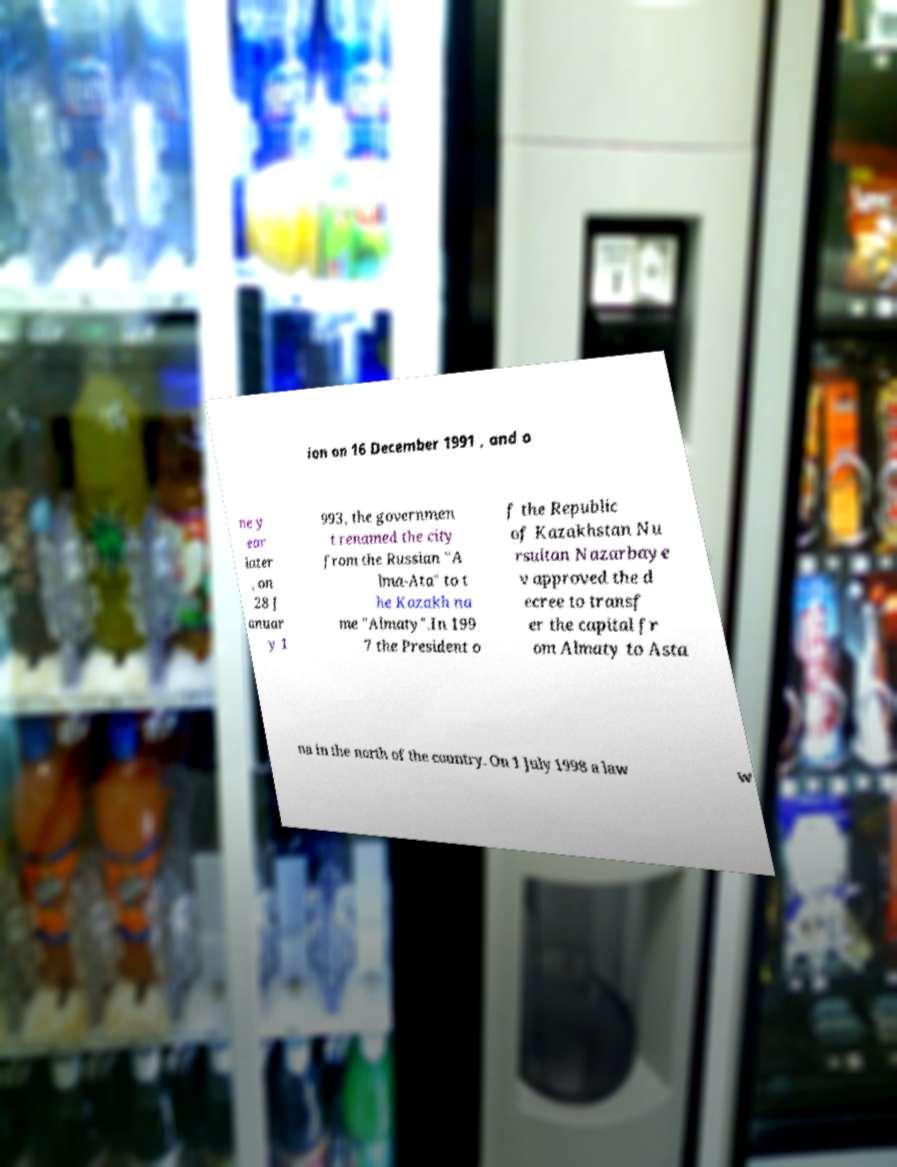What messages or text are displayed in this image? I need them in a readable, typed format. ion on 16 December 1991 , and o ne y ear later , on 28 J anuar y 1 993, the governmen t renamed the city from the Russian "A lma-Ata" to t he Kazakh na me "Almaty".In 199 7 the President o f the Republic of Kazakhstan Nu rsultan Nazarbaye v approved the d ecree to transf er the capital fr om Almaty to Asta na in the north of the country. On 1 July 1998 a law w 